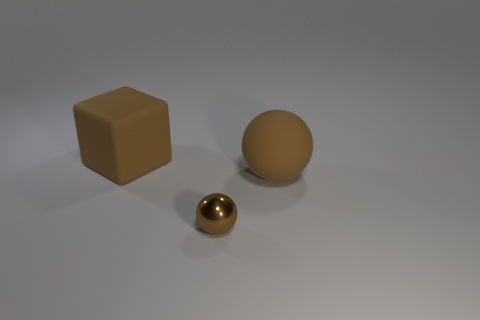The other object that is the same shape as the tiny brown object is what size?
Provide a short and direct response. Large. Do the matte ball and the shiny object have the same color?
Give a very brief answer. Yes. What number of other things are there of the same material as the tiny ball
Offer a very short reply. 0. Is the number of metallic spheres that are in front of the tiny shiny object the same as the number of large brown balls?
Offer a terse response. No. There is a brown thing that is on the left side of the shiny sphere; does it have the same size as the brown rubber sphere?
Ensure brevity in your answer.  Yes. What number of brown objects are to the right of the big matte cube?
Keep it short and to the point. 2. What material is the brown thing that is right of the matte block and behind the small object?
Offer a very short reply. Rubber. How many big objects are either shiny spheres or brown matte cubes?
Your response must be concise. 1. What size is the brown metal sphere?
Keep it short and to the point. Small. Are there fewer brown metallic things that are behind the big brown matte block than big things?
Offer a very short reply. Yes. 